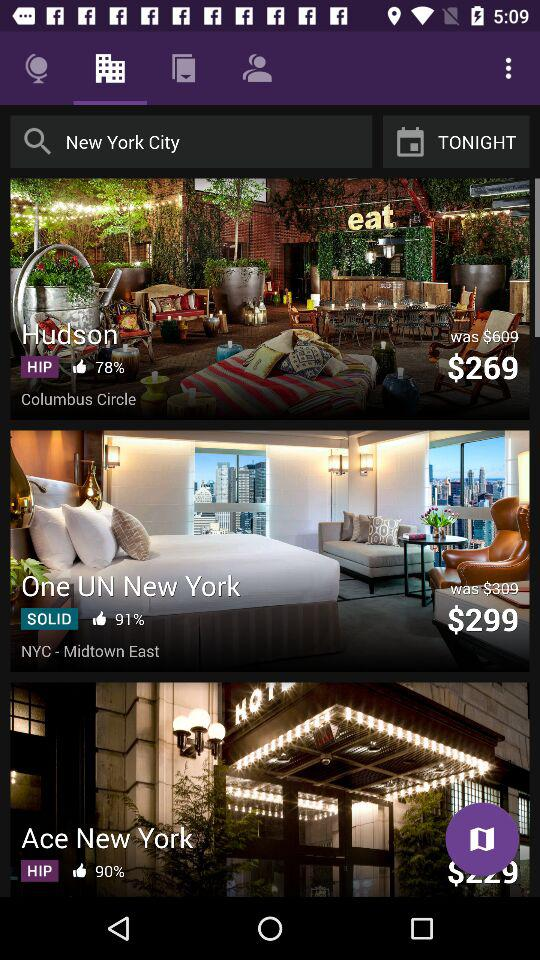What was the previous price of the "Hudson hotel"? The previous price was $609. 